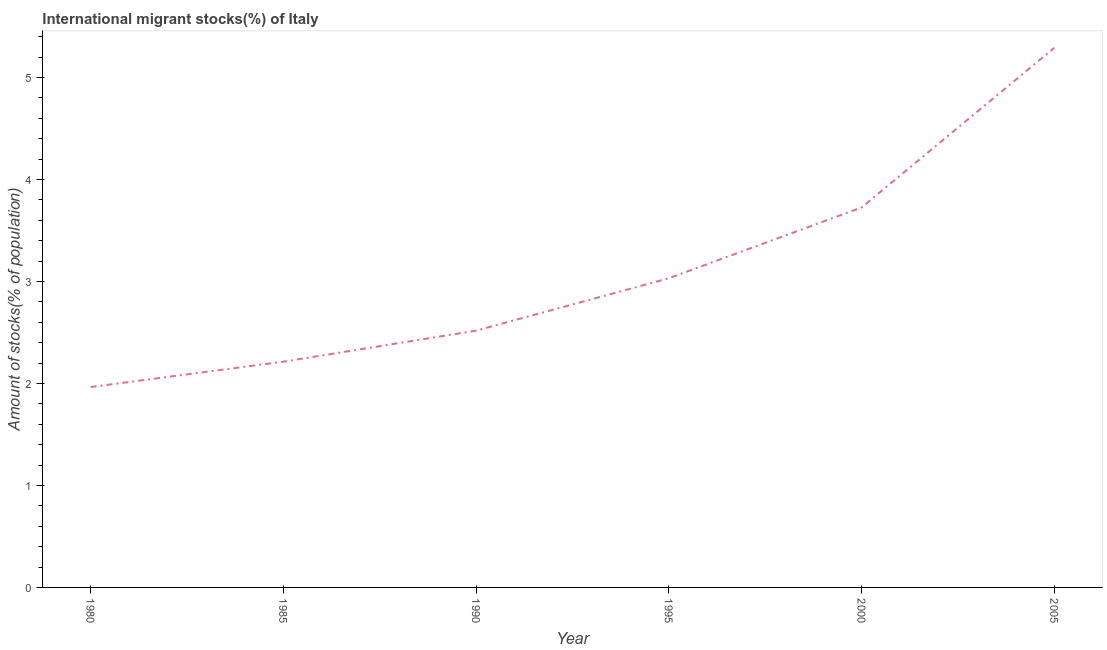What is the number of international migrant stocks in 1995?
Your response must be concise. 3.03. Across all years, what is the maximum number of international migrant stocks?
Offer a very short reply. 5.29. Across all years, what is the minimum number of international migrant stocks?
Give a very brief answer. 1.96. In which year was the number of international migrant stocks maximum?
Provide a short and direct response. 2005. What is the sum of the number of international migrant stocks?
Provide a short and direct response. 18.75. What is the difference between the number of international migrant stocks in 1985 and 1995?
Provide a succinct answer. -0.82. What is the average number of international migrant stocks per year?
Provide a succinct answer. 3.12. What is the median number of international migrant stocks?
Offer a very short reply. 2.77. What is the ratio of the number of international migrant stocks in 1990 to that in 2000?
Provide a short and direct response. 0.68. Is the difference between the number of international migrant stocks in 1980 and 2000 greater than the difference between any two years?
Offer a terse response. No. What is the difference between the highest and the second highest number of international migrant stocks?
Your response must be concise. 1.57. What is the difference between the highest and the lowest number of international migrant stocks?
Offer a very short reply. 3.33. Does the number of international migrant stocks monotonically increase over the years?
Offer a terse response. Yes. Does the graph contain grids?
Your answer should be very brief. No. What is the title of the graph?
Ensure brevity in your answer.  International migrant stocks(%) of Italy. What is the label or title of the X-axis?
Your answer should be compact. Year. What is the label or title of the Y-axis?
Ensure brevity in your answer.  Amount of stocks(% of population). What is the Amount of stocks(% of population) in 1980?
Your answer should be compact. 1.96. What is the Amount of stocks(% of population) of 1985?
Keep it short and to the point. 2.21. What is the Amount of stocks(% of population) of 1990?
Ensure brevity in your answer.  2.52. What is the Amount of stocks(% of population) of 1995?
Offer a terse response. 3.03. What is the Amount of stocks(% of population) of 2000?
Ensure brevity in your answer.  3.73. What is the Amount of stocks(% of population) of 2005?
Offer a very short reply. 5.29. What is the difference between the Amount of stocks(% of population) in 1980 and 1985?
Your answer should be very brief. -0.25. What is the difference between the Amount of stocks(% of population) in 1980 and 1990?
Provide a short and direct response. -0.55. What is the difference between the Amount of stocks(% of population) in 1980 and 1995?
Ensure brevity in your answer.  -1.07. What is the difference between the Amount of stocks(% of population) in 1980 and 2000?
Your answer should be compact. -1.76. What is the difference between the Amount of stocks(% of population) in 1980 and 2005?
Provide a short and direct response. -3.33. What is the difference between the Amount of stocks(% of population) in 1985 and 1990?
Provide a short and direct response. -0.3. What is the difference between the Amount of stocks(% of population) in 1985 and 1995?
Your answer should be compact. -0.82. What is the difference between the Amount of stocks(% of population) in 1985 and 2000?
Your response must be concise. -1.51. What is the difference between the Amount of stocks(% of population) in 1985 and 2005?
Your response must be concise. -3.08. What is the difference between the Amount of stocks(% of population) in 1990 and 1995?
Provide a succinct answer. -0.51. What is the difference between the Amount of stocks(% of population) in 1990 and 2000?
Your answer should be compact. -1.21. What is the difference between the Amount of stocks(% of population) in 1990 and 2005?
Your response must be concise. -2.77. What is the difference between the Amount of stocks(% of population) in 1995 and 2000?
Your response must be concise. -0.69. What is the difference between the Amount of stocks(% of population) in 1995 and 2005?
Your answer should be compact. -2.26. What is the difference between the Amount of stocks(% of population) in 2000 and 2005?
Your answer should be very brief. -1.57. What is the ratio of the Amount of stocks(% of population) in 1980 to that in 1985?
Your response must be concise. 0.89. What is the ratio of the Amount of stocks(% of population) in 1980 to that in 1990?
Offer a terse response. 0.78. What is the ratio of the Amount of stocks(% of population) in 1980 to that in 1995?
Your response must be concise. 0.65. What is the ratio of the Amount of stocks(% of population) in 1980 to that in 2000?
Keep it short and to the point. 0.53. What is the ratio of the Amount of stocks(% of population) in 1980 to that in 2005?
Ensure brevity in your answer.  0.37. What is the ratio of the Amount of stocks(% of population) in 1985 to that in 1990?
Your response must be concise. 0.88. What is the ratio of the Amount of stocks(% of population) in 1985 to that in 1995?
Your response must be concise. 0.73. What is the ratio of the Amount of stocks(% of population) in 1985 to that in 2000?
Offer a very short reply. 0.59. What is the ratio of the Amount of stocks(% of population) in 1985 to that in 2005?
Offer a very short reply. 0.42. What is the ratio of the Amount of stocks(% of population) in 1990 to that in 1995?
Your response must be concise. 0.83. What is the ratio of the Amount of stocks(% of population) in 1990 to that in 2000?
Provide a succinct answer. 0.68. What is the ratio of the Amount of stocks(% of population) in 1990 to that in 2005?
Your answer should be very brief. 0.48. What is the ratio of the Amount of stocks(% of population) in 1995 to that in 2000?
Keep it short and to the point. 0.81. What is the ratio of the Amount of stocks(% of population) in 1995 to that in 2005?
Ensure brevity in your answer.  0.57. What is the ratio of the Amount of stocks(% of population) in 2000 to that in 2005?
Ensure brevity in your answer.  0.7. 